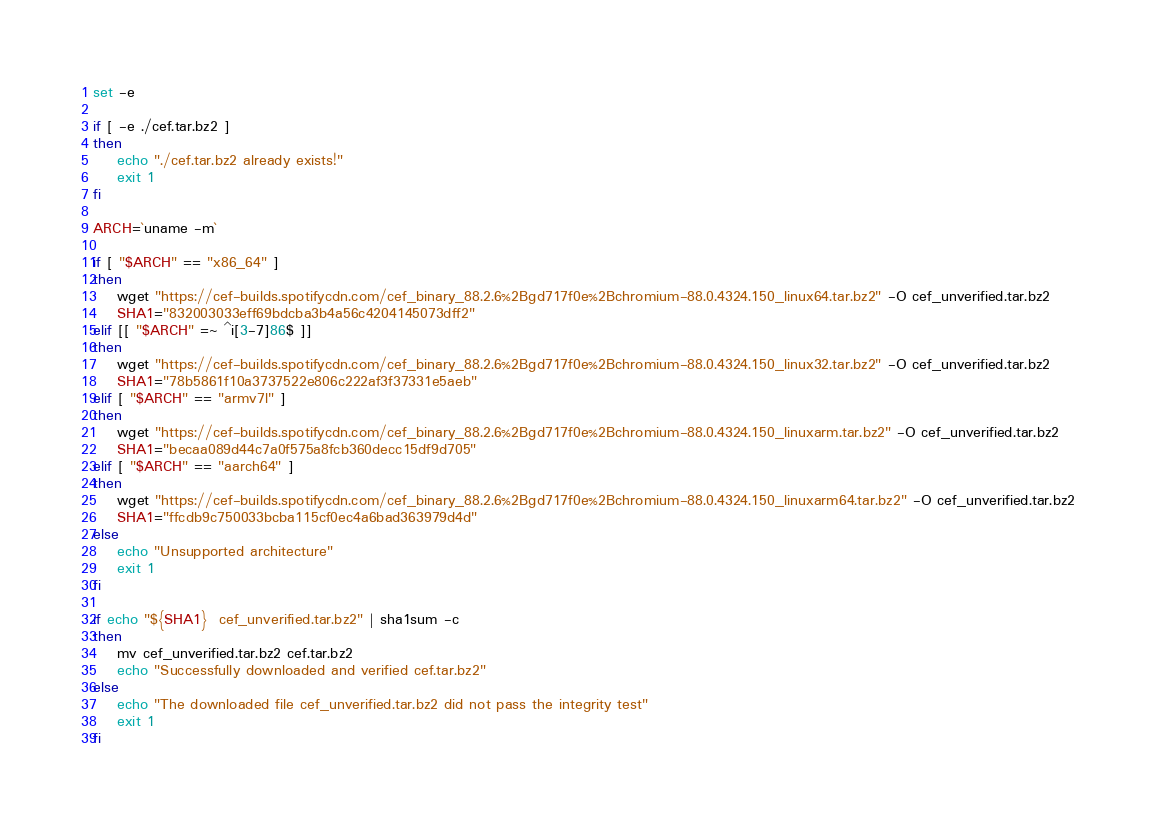<code> <loc_0><loc_0><loc_500><loc_500><_Bash_>set -e

if [ -e ./cef.tar.bz2 ]
then
    echo "./cef.tar.bz2 already exists!"
    exit 1
fi

ARCH=`uname -m`

if [ "$ARCH" == "x86_64" ]
then
    wget "https://cef-builds.spotifycdn.com/cef_binary_88.2.6%2Bgd717f0e%2Bchromium-88.0.4324.150_linux64.tar.bz2" -O cef_unverified.tar.bz2
    SHA1="832003033eff69bdcba3b4a56c4204145073dff2"
elif [[ "$ARCH" =~ ^i[3-7]86$ ]]
then
    wget "https://cef-builds.spotifycdn.com/cef_binary_88.2.6%2Bgd717f0e%2Bchromium-88.0.4324.150_linux32.tar.bz2" -O cef_unverified.tar.bz2
    SHA1="78b5861f10a3737522e806c222af3f37331e5aeb"
elif [ "$ARCH" == "armv7l" ]
then
    wget "https://cef-builds.spotifycdn.com/cef_binary_88.2.6%2Bgd717f0e%2Bchromium-88.0.4324.150_linuxarm.tar.bz2" -O cef_unverified.tar.bz2
    SHA1="becaa089d44c7a0f575a8fcb360decc15df9d705"
elif [ "$ARCH" == "aarch64" ]
then
    wget "https://cef-builds.spotifycdn.com/cef_binary_88.2.6%2Bgd717f0e%2Bchromium-88.0.4324.150_linuxarm64.tar.bz2" -O cef_unverified.tar.bz2
    SHA1="ffcdb9c750033bcba115cf0ec4a6bad363979d4d"
else
    echo "Unsupported architecture"
    exit 1
fi

if echo "${SHA1}  cef_unverified.tar.bz2" | sha1sum -c
then
    mv cef_unverified.tar.bz2 cef.tar.bz2
    echo "Successfully downloaded and verified cef.tar.bz2"
else
    echo "The downloaded file cef_unverified.tar.bz2 did not pass the integrity test"
    exit 1
fi
</code> 